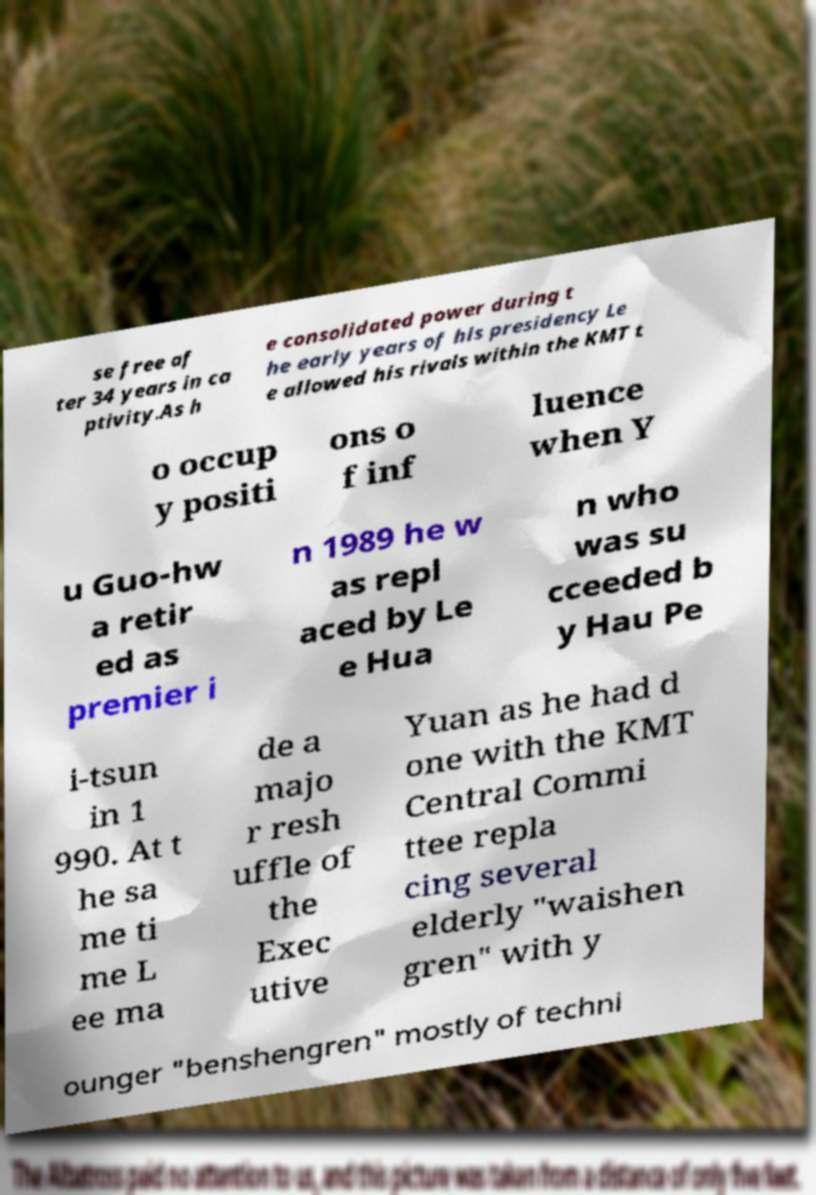There's text embedded in this image that I need extracted. Can you transcribe it verbatim? se free af ter 34 years in ca ptivity.As h e consolidated power during t he early years of his presidency Le e allowed his rivals within the KMT t o occup y positi ons o f inf luence when Y u Guo-hw a retir ed as premier i n 1989 he w as repl aced by Le e Hua n who was su cceeded b y Hau Pe i-tsun in 1 990. At t he sa me ti me L ee ma de a majo r resh uffle of the Exec utive Yuan as he had d one with the KMT Central Commi ttee repla cing several elderly "waishen gren" with y ounger "benshengren" mostly of techni 